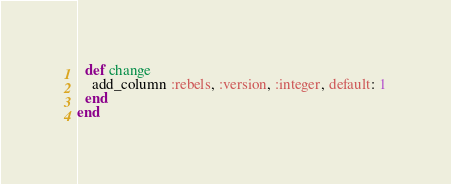<code> <loc_0><loc_0><loc_500><loc_500><_Ruby_>  def change
    add_column :rebels, :version, :integer, default: 1
  end
end
</code> 